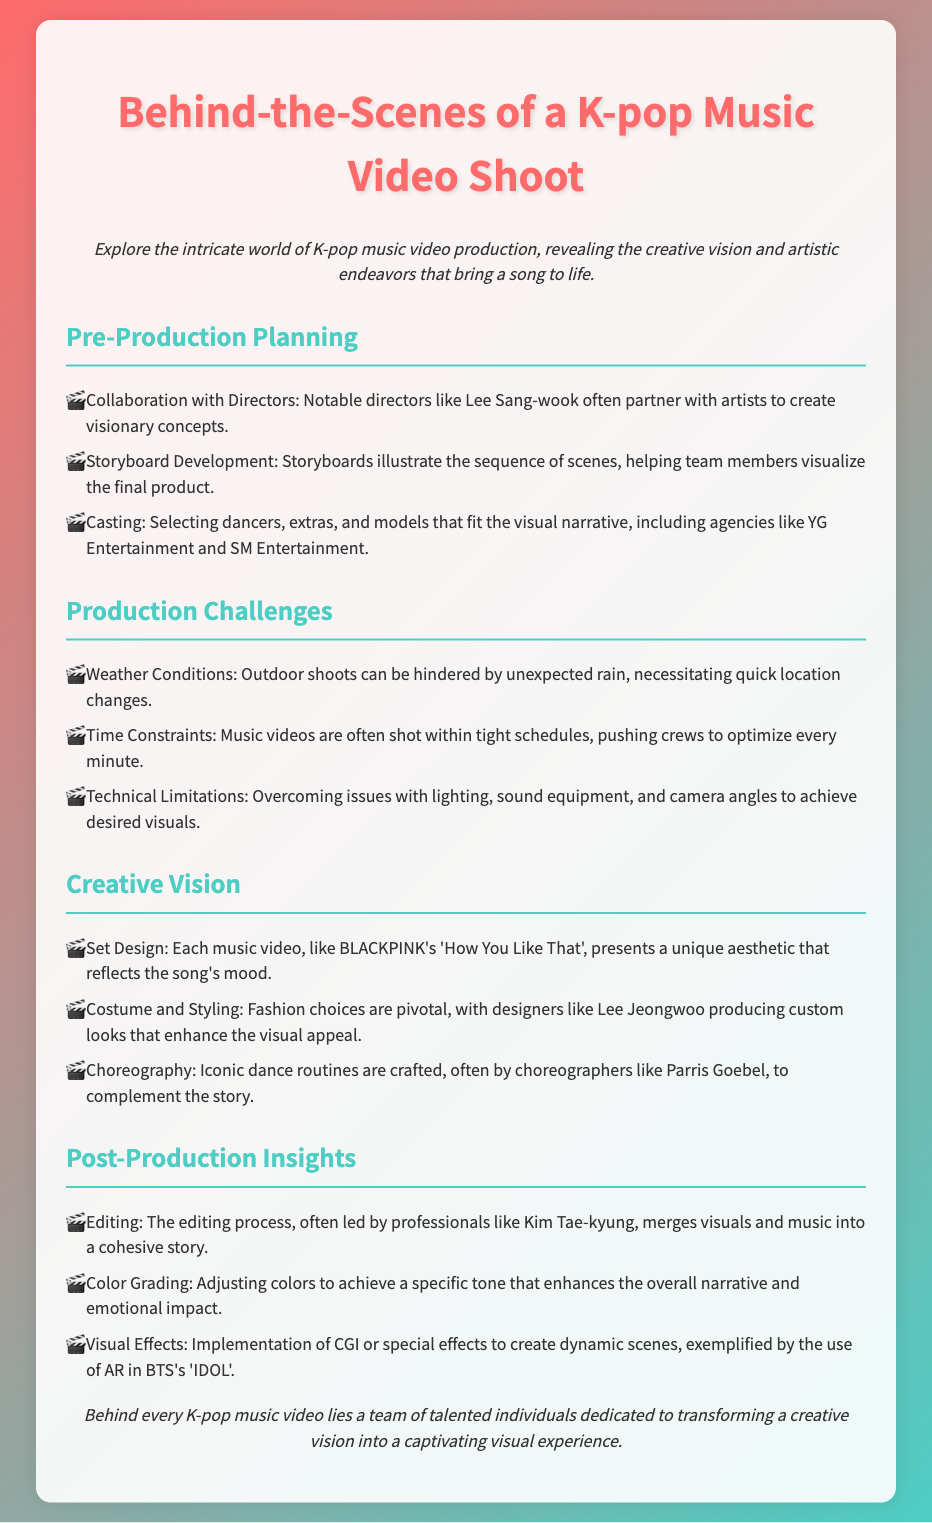What is the name of the notable director mentioned? The document mentions notable directors like Lee Sang-wook, who collaborate with artists.
Answer: Lee Sang-wook What type of visuals are enhanced by costume choices? Costume and styling choices are pivotal for enhancing the visual appeal of music videos.
Answer: Visual appeal Which K-pop group is referenced in the context of set design? BLACKPINK's 'How You Like That' is cited as an example of unique set design reflecting the song's mood.
Answer: BLACKPINK What unique element is often implemented in post-production? The document mentions visual effects like CGI or special effects created in post-production.
Answer: CGI Who often leads the editing process? The editing is often led by professionals like Kim Tae-kyung, who plays a key role in merging visuals and music.
Answer: Kim Tae-kyung What challenge do crews face related to weather during shoots? The document specifies that outdoor shoots can be hindered by unexpected rain, necessitating quick location changes.
Answer: Unexpected rain Which choreographer is known for working on iconic dance routines? Choreographers like Parris Goebel are mentioned as responsible for creating iconic dance routines.
Answer: Parris Goebel What element of music video production can be affected by tight schedules? Time constraints impact the optimization of every minute during the music video shoots.
Answer: Time constraints 